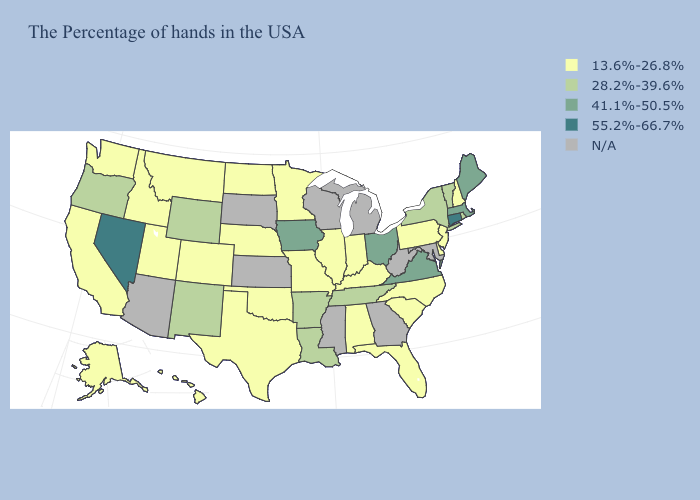What is the value of Alabama?
Keep it brief. 13.6%-26.8%. What is the lowest value in the USA?
Keep it brief. 13.6%-26.8%. Among the states that border Utah , does Idaho have the highest value?
Be succinct. No. What is the lowest value in the South?
Answer briefly. 13.6%-26.8%. Name the states that have a value in the range 13.6%-26.8%?
Be succinct. New Hampshire, New Jersey, Delaware, Pennsylvania, North Carolina, South Carolina, Florida, Kentucky, Indiana, Alabama, Illinois, Missouri, Minnesota, Nebraska, Oklahoma, Texas, North Dakota, Colorado, Utah, Montana, Idaho, California, Washington, Alaska, Hawaii. What is the value of Washington?
Short answer required. 13.6%-26.8%. What is the lowest value in states that border Oregon?
Keep it brief. 13.6%-26.8%. What is the value of New Mexico?
Write a very short answer. 28.2%-39.6%. Does Iowa have the lowest value in the USA?
Keep it brief. No. Among the states that border New York , does New Jersey have the highest value?
Concise answer only. No. Name the states that have a value in the range 13.6%-26.8%?
Short answer required. New Hampshire, New Jersey, Delaware, Pennsylvania, North Carolina, South Carolina, Florida, Kentucky, Indiana, Alabama, Illinois, Missouri, Minnesota, Nebraska, Oklahoma, Texas, North Dakota, Colorado, Utah, Montana, Idaho, California, Washington, Alaska, Hawaii. What is the value of Illinois?
Concise answer only. 13.6%-26.8%. Does the first symbol in the legend represent the smallest category?
Be succinct. Yes. 